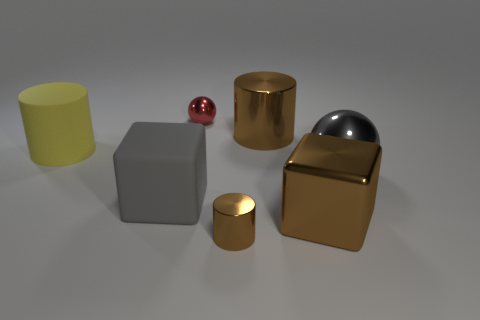Can you tell which object is the smallest in this collection? Among the collection of objects in the image, the small red spherical object appears to be the smallest. It's positioned near the center and is noticeably smaller compared to the other shapes. 